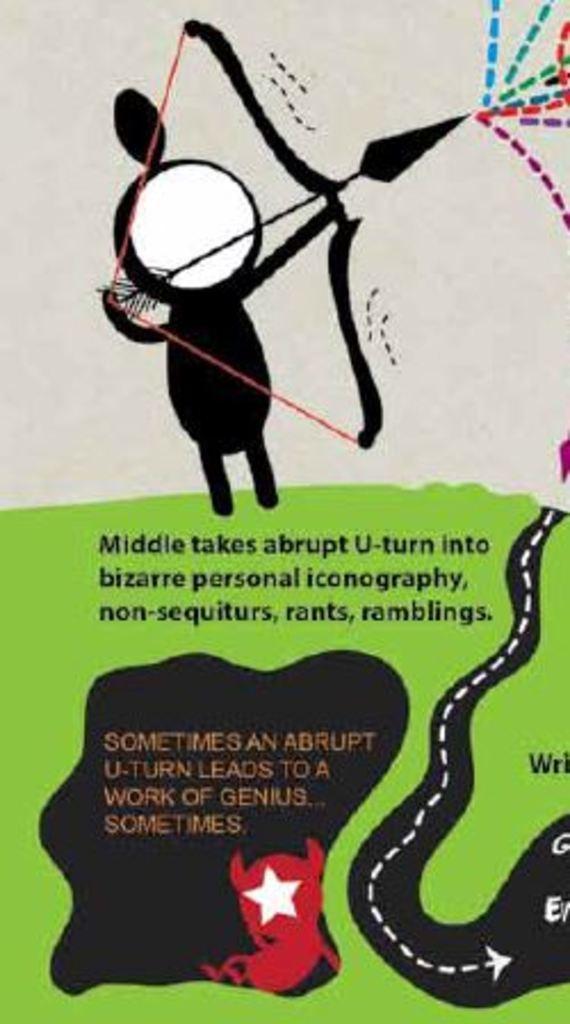How would you summarize this image in a sentence or two? In this image, I can see a poster with cartoon pictures and text. 